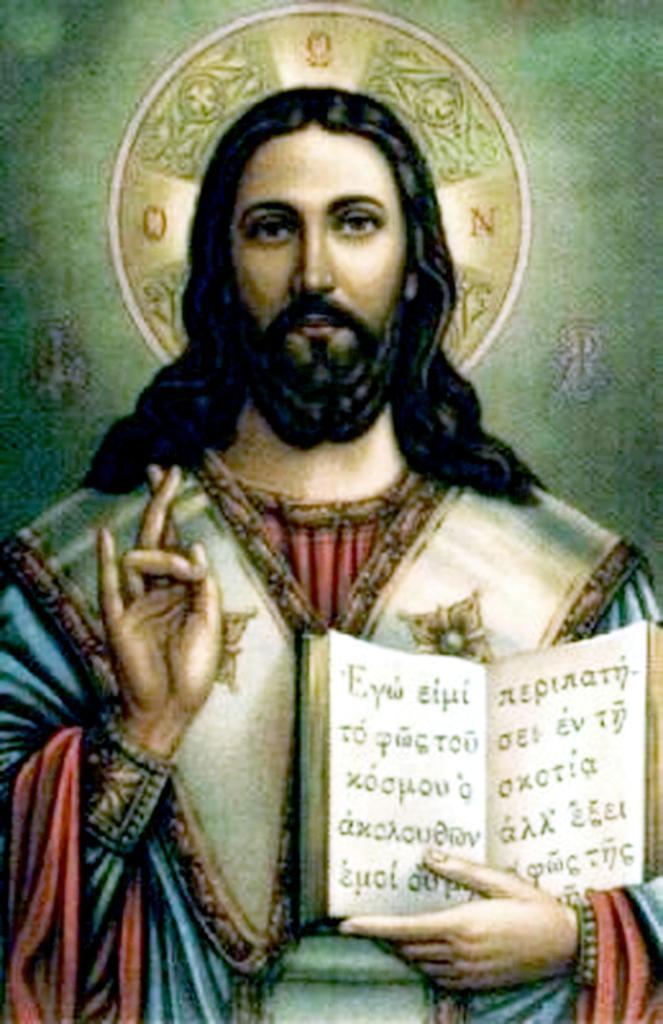Could you give a brief overview of what you see in this image? In this image there is a depiction of a person holding a book. 